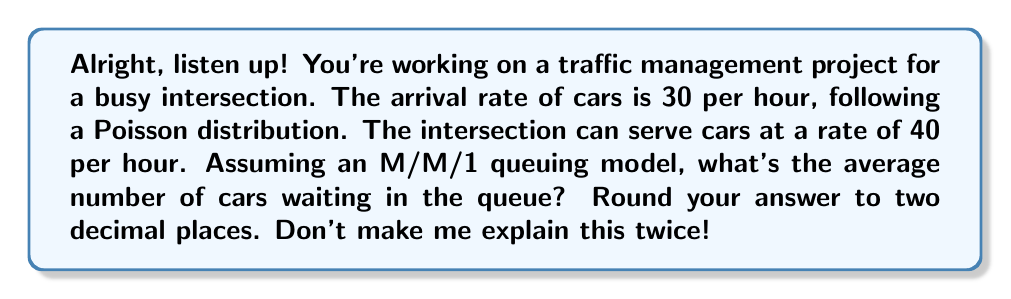Teach me how to tackle this problem. Okay, let's break this down step-by-step. Try to keep up!

1) First, we need to identify the key parameters:
   $\lambda$ = arrival rate = 30 cars/hour
   $\mu$ = service rate = 40 cars/hour

2) For an M/M/1 queue to be stable, we need $\rho = \frac{\lambda}{\mu} < 1$. Let's check:
   
   $\rho = \frac{30}{40} = 0.75 < 1$, so we're good to go.

3) Now, the average number of cars in the queue (not including the one being served) is given by the formula:

   $$L_q = \frac{\rho^2}{1-\rho}$$

4) Let's plug in our value for $\rho$:

   $$L_q = \frac{0.75^2}{1-0.75} = \frac{0.5625}{0.25} = 2.25$$

5) Rounding to two decimal places: 2.25

And there you have it! Not so hard when you actually pay attention, right?
Answer: 2.25 cars 